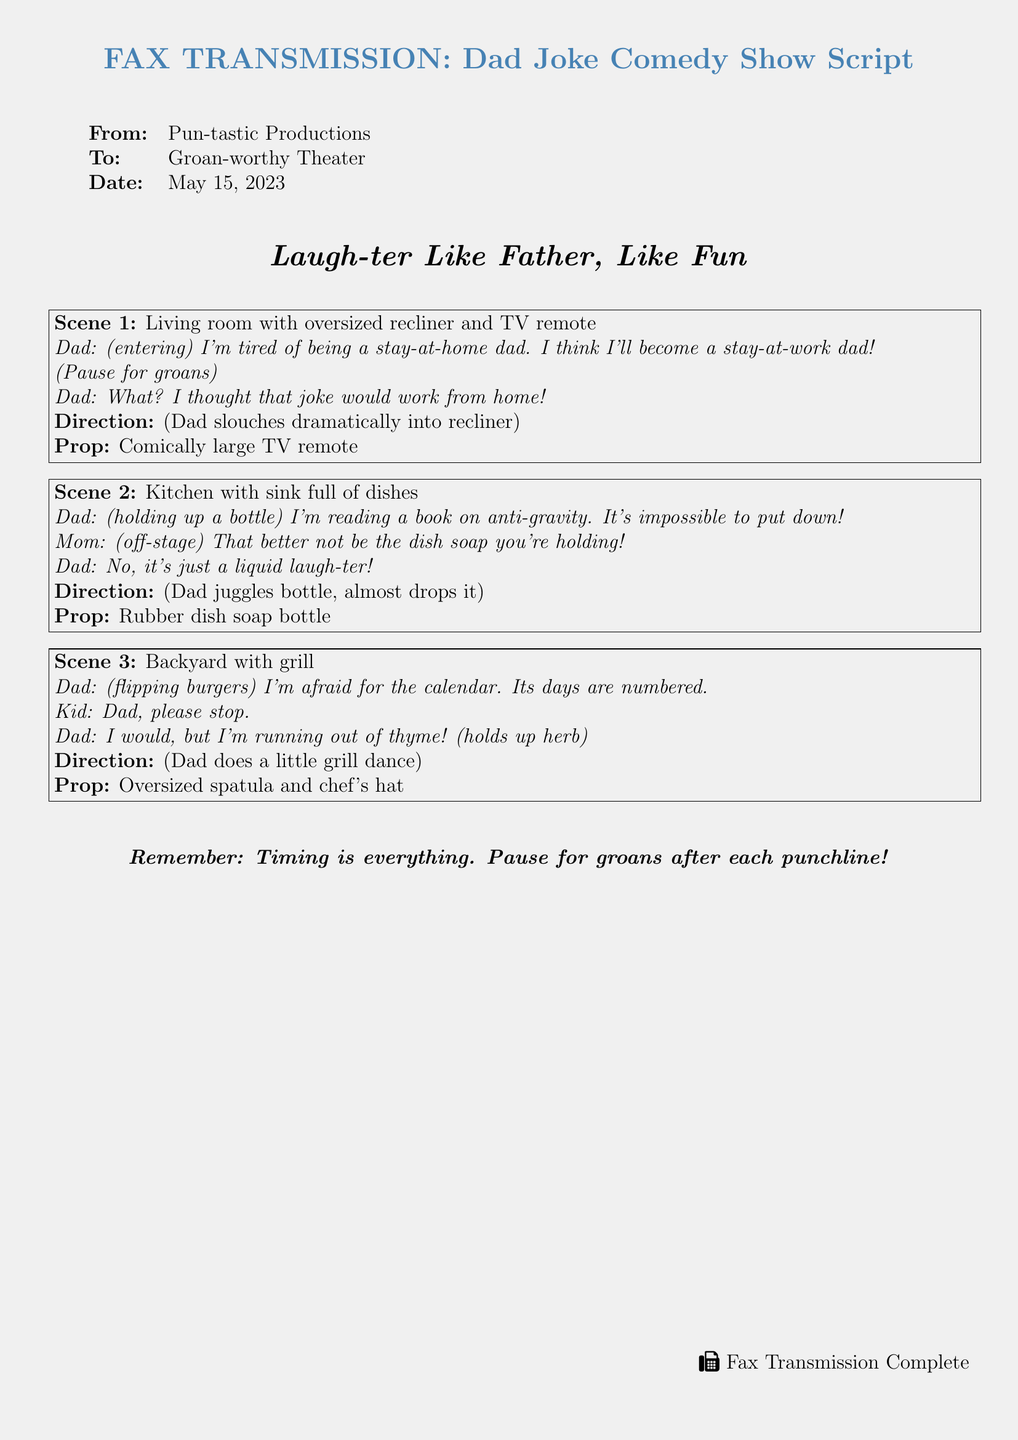what is the title of the comedy show? The title is mentioned at the center of the document as "Laugh-ter Like Father, Like Fun."
Answer: Laugh-ter Like Father, Like Fun who is the sender of the fax? The sender is listed in the "From" section of the document as "Pun-tastic Productions."
Answer: Pun-tastic Productions what is the date of the fax? The date is specified in the "Date" section of the document as "May 15, 2023."
Answer: May 15, 2023 what prop is used in Scene 1? The prop for Scene 1 is mentioned as a "Comically large TV remote."
Answer: Comically large TV remote how many scenes are in the document? There are three distinct scenes outlined in the document.
Answer: 3 what is the punchline of the joke in Scene 3? The punchline is mentioned as "I would, but I'm running out of thyme!"
Answer: I would, but I'm running out of thyme! what is the theme of the jokes in the document? The theme is indicated by the title and context of the jokes, which revolve around dad jokes and puns.
Answer: Dad jokes what does the document say about timing? The document advises that "Timing is everything. Pause for groans after each punchline!"
Answer: Timing is everything 